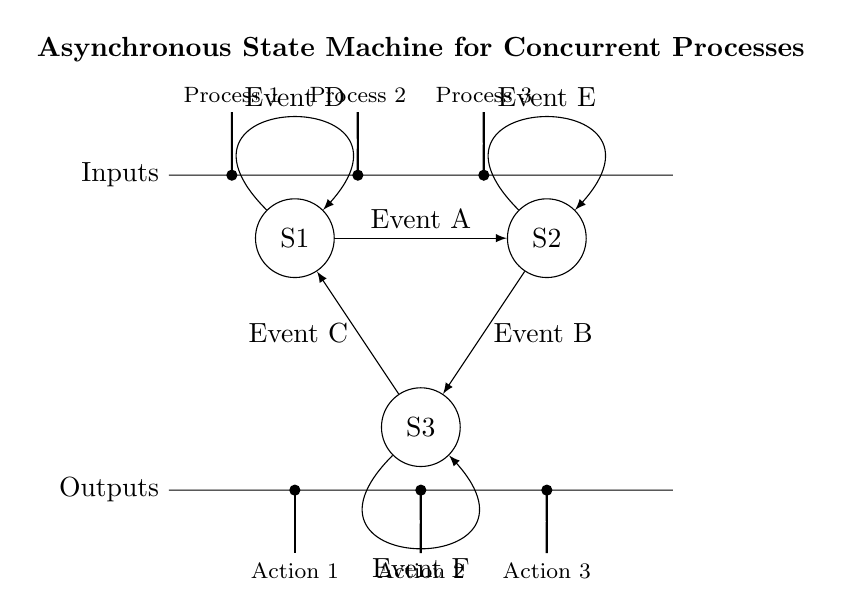What are the states in this asynchronous state machine? The states are represented by the circles in the diagram, labeled S1, S2, and S3.
Answer: S1, S2, S3 What event leads from state S1 to state S2? The diagram shows a transition arrow from S1 to S2 labeled "Event A", which indicates the event that causes this transition.
Answer: Event A How many processes are represented in the circuit? The circuit has three input processes represented by the lines connecting to the states, labeled as "Process 1", "Process 2", and "Process 3".
Answer: Three Which state has a self-loop? The diagram indicates that all three states (S1, S2, and S3) have self-loops, as indicated by arrows that return to the originating state with the corresponding events.
Answer: S1, S2, S3 What event causes a transition from S2 to S3? The transition from S2 to S3 is labeled "Event B", which is the event responsible for this change in state.
Answer: Event B What is the purpose of self-loops in this state machine? Self-loops allow a state to remain in its current state in response to specific events (D for S1, E for S2, and F for S3), indicating that the process can react to these events without changing state.
Answer: To handle events What is the direction of the transition from S3 to S1? The transition from S3 to S1 goes in the direction indicated by an arrow pointing from S3 to S1, showing the flow of state changes in the machine.
Answer: Counterclockwise 